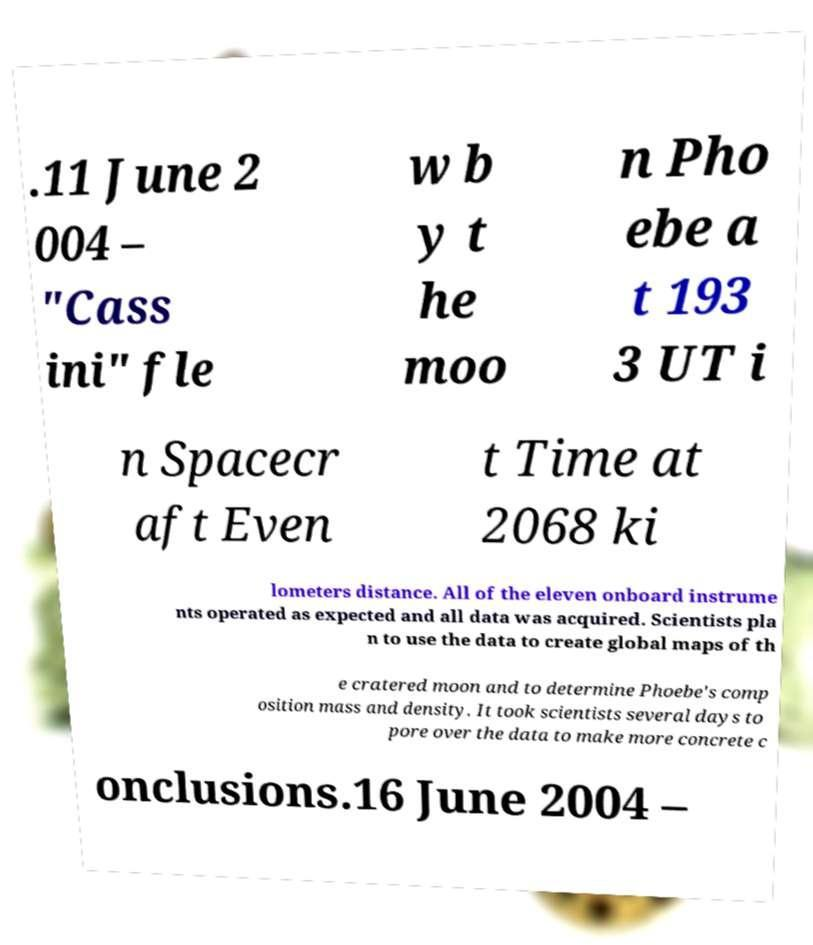Can you accurately transcribe the text from the provided image for me? .11 June 2 004 – "Cass ini" fle w b y t he moo n Pho ebe a t 193 3 UT i n Spacecr aft Even t Time at 2068 ki lometers distance. All of the eleven onboard instrume nts operated as expected and all data was acquired. Scientists pla n to use the data to create global maps of th e cratered moon and to determine Phoebe's comp osition mass and density. It took scientists several days to pore over the data to make more concrete c onclusions.16 June 2004 – 